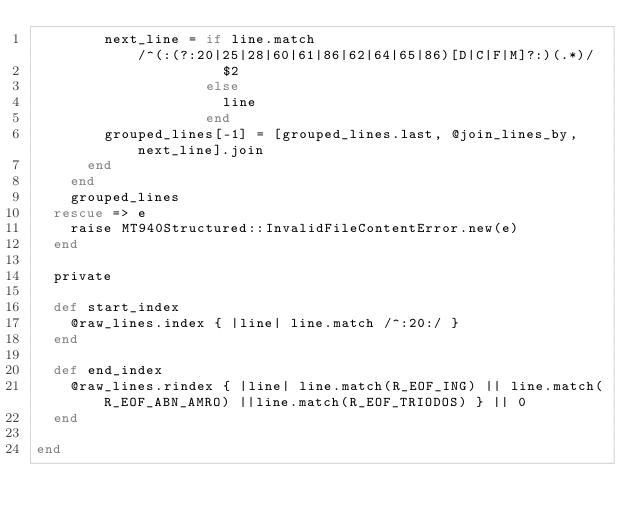Convert code to text. <code><loc_0><loc_0><loc_500><loc_500><_Ruby_>        next_line = if line.match /^(:(?:20|25|28|60|61|86|62|64|65|86)[D|C|F|M]?:)(.*)/
                      $2
                    else
                      line
                    end
        grouped_lines[-1] = [grouped_lines.last, @join_lines_by, next_line].join
      end
    end
    grouped_lines
  rescue => e
    raise MT940Structured::InvalidFileContentError.new(e)
  end

  private

  def start_index
    @raw_lines.index { |line| line.match /^:20:/ }
  end

  def end_index
    @raw_lines.rindex { |line| line.match(R_EOF_ING) || line.match(R_EOF_ABN_AMRO) ||line.match(R_EOF_TRIODOS) } || 0
  end

end
</code> 